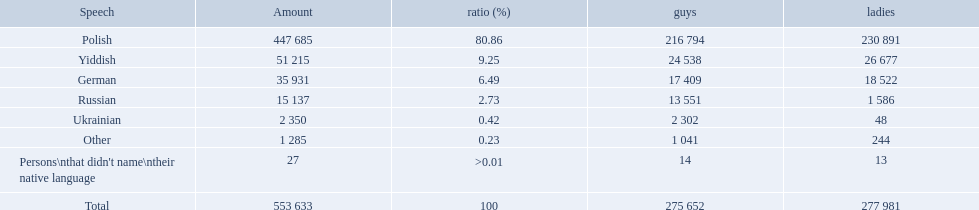What was the least spoken language Ukrainian. What was the most spoken? Polish. What languages are there? Polish, Yiddish, German, Russian, Ukrainian. What numbers speak these languages? 447 685, 51 215, 35 931, 15 137, 2 350. What numbers are not listed as speaking these languages? 1 285, 27. What are the totals of these speakers? 553 633. How many speakers are represented in polish? 447 685. How many represented speakers are yiddish? 51 215. What is the total number of speakers? 553 633. Which language options are listed? Polish, Yiddish, German, Russian, Ukrainian, Other, Persons\nthat didn't name\ntheir native language. Of these, which did .42% of the people select? Ukrainian. Parse the full table in json format. {'header': ['Speech', 'Amount', 'ratio (%)', 'guys', 'ladies'], 'rows': [['Polish', '447 685', '80.86', '216 794', '230 891'], ['Yiddish', '51 215', '9.25', '24 538', '26 677'], ['German', '35 931', '6.49', '17 409', '18 522'], ['Russian', '15 137', '2.73', '13 551', '1 586'], ['Ukrainian', '2 350', '0.42', '2 302', '48'], ['Other', '1 285', '0.23', '1 041', '244'], ["Persons\\nthat didn't name\\ntheir native language", '27', '>0.01', '14', '13'], ['Total', '553 633', '100', '275 652', '277 981']]} What were the languages in plock governorate? Polish, Yiddish, German, Russian, Ukrainian, Other. Which language has a value of .42? Ukrainian. 